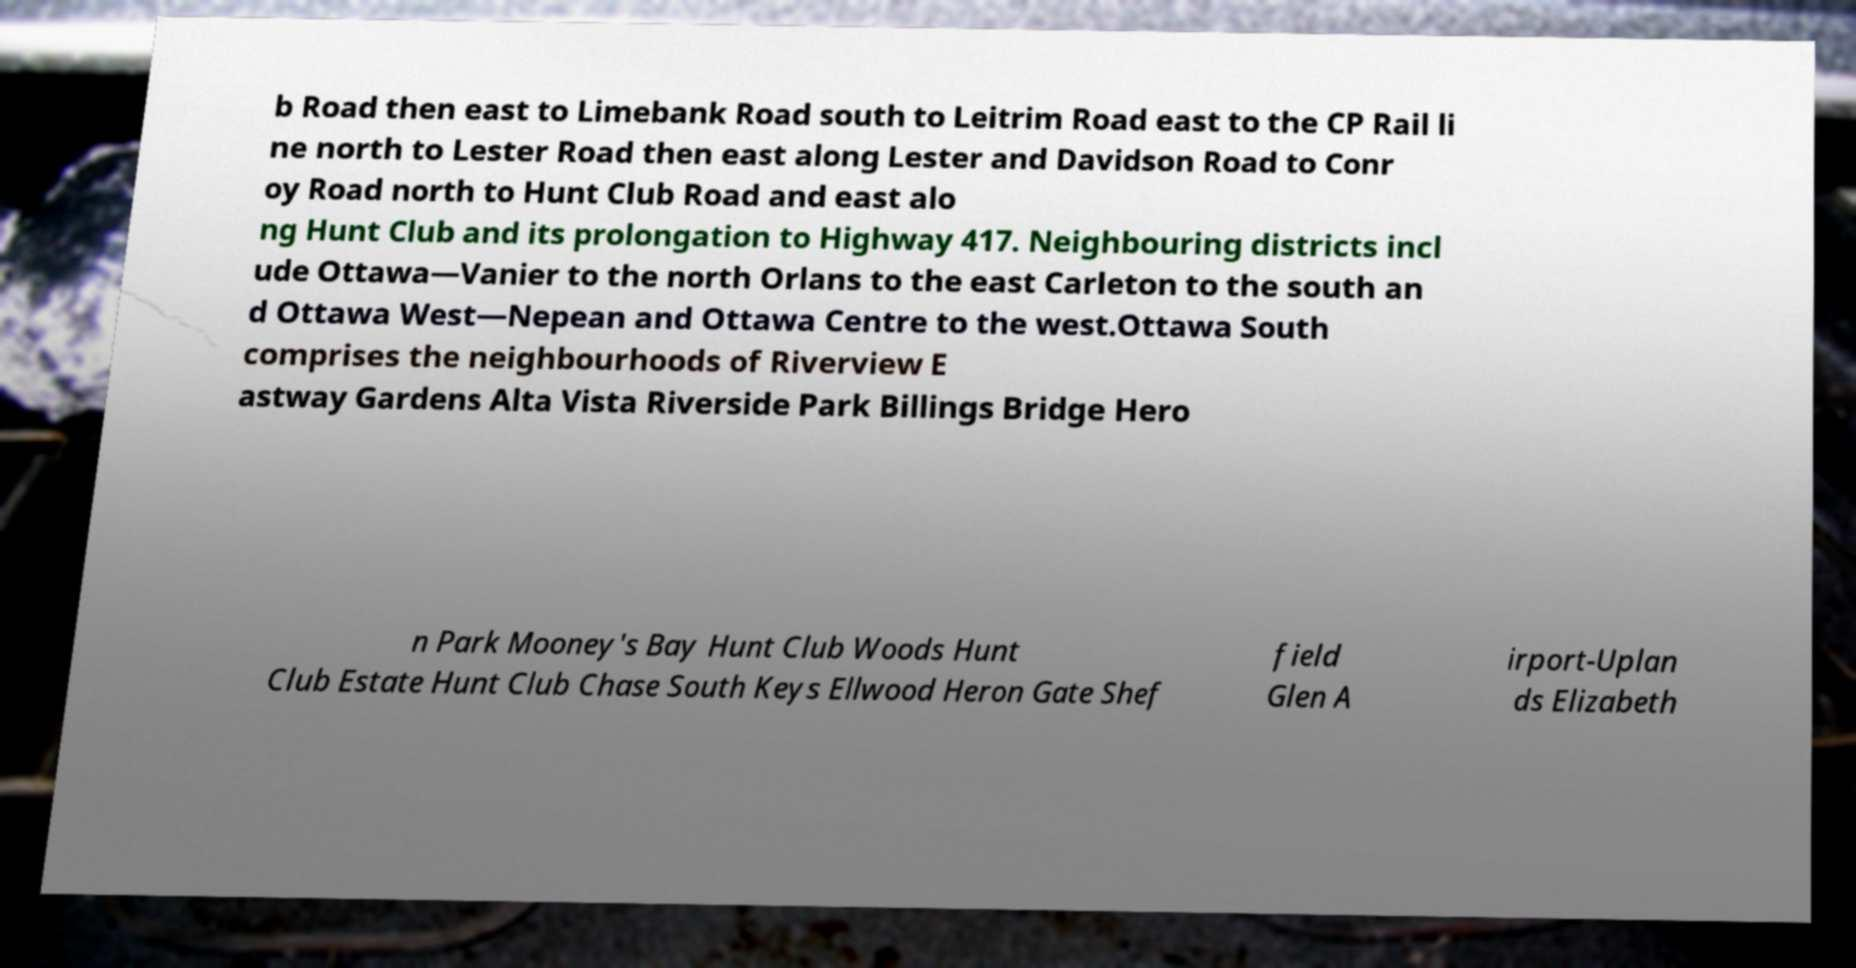Could you extract and type out the text from this image? b Road then east to Limebank Road south to Leitrim Road east to the CP Rail li ne north to Lester Road then east along Lester and Davidson Road to Conr oy Road north to Hunt Club Road and east alo ng Hunt Club and its prolongation to Highway 417. Neighbouring districts incl ude Ottawa—Vanier to the north Orlans to the east Carleton to the south an d Ottawa West—Nepean and Ottawa Centre to the west.Ottawa South comprises the neighbourhoods of Riverview E astway Gardens Alta Vista Riverside Park Billings Bridge Hero n Park Mooney's Bay Hunt Club Woods Hunt Club Estate Hunt Club Chase South Keys Ellwood Heron Gate Shef field Glen A irport-Uplan ds Elizabeth 